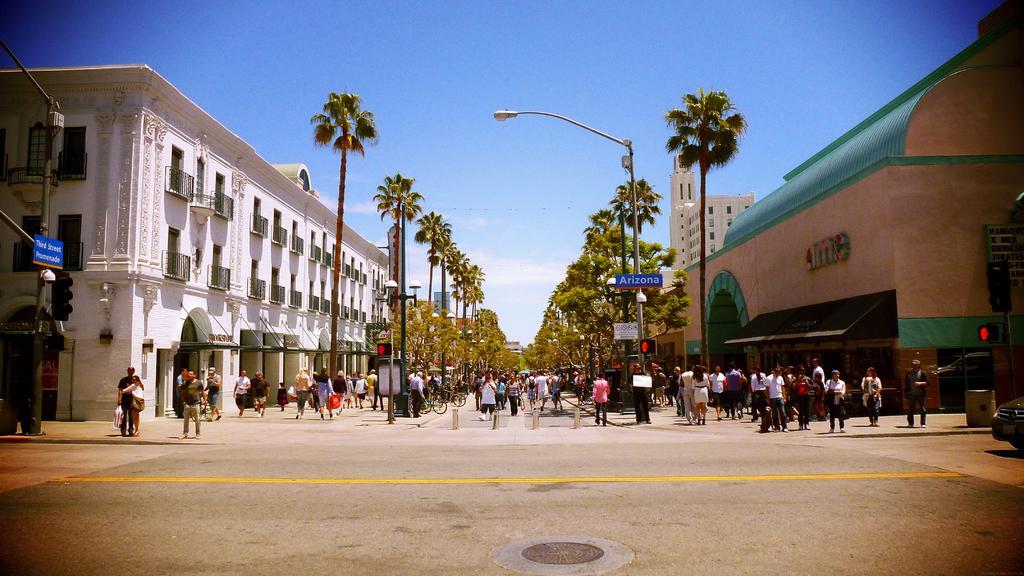Describe this image in one or two sentences. This picture shows few buildings and we see trees on the either side of the road and couple of pole lights and we see people walking and few are standing and we see few people carrying bags in their hands and we see traffic signal lights and a blue cloudy sky. 